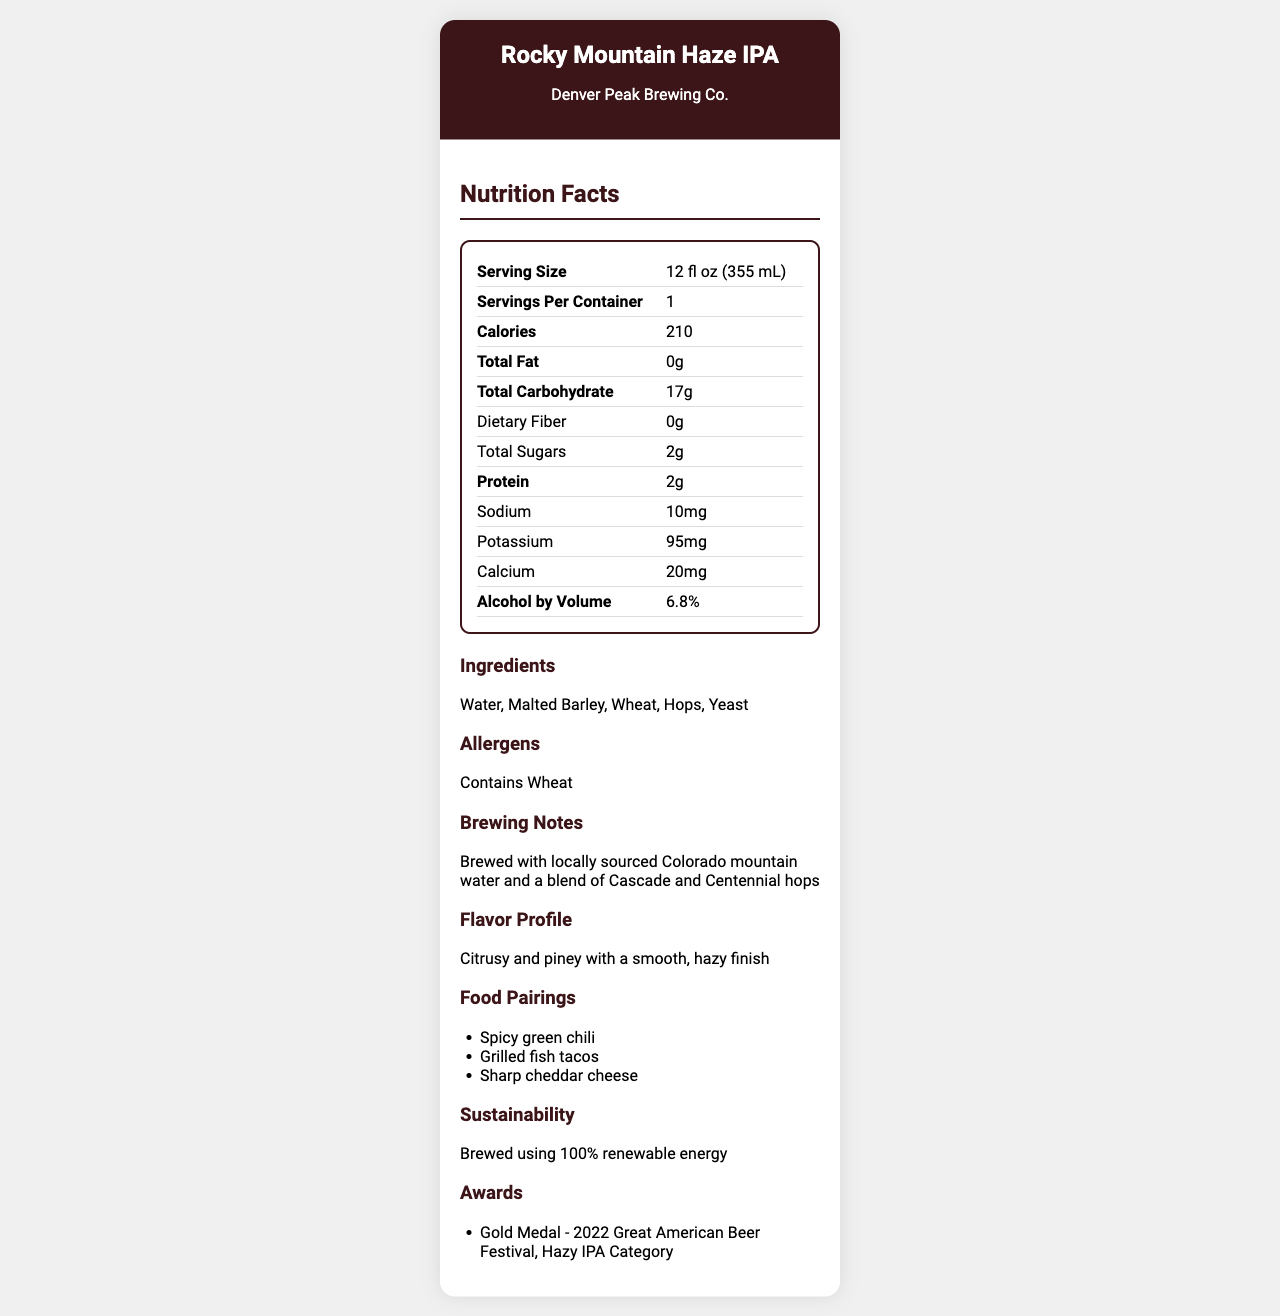what is the serving size of Rocky Mountain Haze IPA? The serving size is listed as "12 fl oz (355 mL)" in the Nutrition Facts table.
Answer: 12 fl oz (355 mL) how many carbohydrates are in a serving? The Nutrition Facts section indicates that the total carbohydrate content per serving is 17 grams.
Answer: 17 grams what is the alcohol content of Rocky Mountain Haze IPA? The Alcohol by Volume (ABV) is stated as 6.8% in the Nutrition Facts section.
Answer: 6.8% how many calories are in one serving of Rocky Mountain Haze IPA? The number of calories per serving is given as 210 in the Nutrition Facts section.
Answer: 210 calories what ingredients are used to brew Rocky Mountain Haze IPA? The Ingredients section lists Water, Malted Barley, Wheat, Hops, and Yeast.
Answer: Water, Malted Barley, Wheat, Hops, Yeast how much protein is in a serving? The Nutrition Facts table shows that there are 2 grams of protein per serving.
Answer: 2 grams how much potassium does one serving contain? The amount of potassium per serving is listed as 95 milligrams in the Nutrition Facts section.
Answer: 95 milligrams which allergen is mentioned for Rocky Mountain Haze IPA? The Allergens section specifies that the product contains Wheat.
Answer: Wheat What is the brewery that produces Rocky Mountain Haze IPA? The document mentions that the brewery is Denver Peak Brewing Co.
Answer: Denver Peak Brewing Co. what award did Rocky Mountain Haze IPA win? The Awards section states that the beer won the Gold Medal in the Hazy IPA Category at the 2022 Great American Beer Festival.
Answer: Gold Medal - 2022 Great American Beer Festival, Hazy IPA Category what is the flavor profile of Rocky Mountain Haze IPA? The Flavor Profile section describes it as "Citrusy and piney with a smooth, hazy finish."
Answer: Citrusy and piney with a smooth, hazy finish what food pairings are suggested for Rocky Mountain Haze IPA? A. Grilled chicken B. Spicy green chili C. Caesar salad D. Sushi The Food Pairings section suggests Spicy green chili, Grilled fish tacos, and Sharp cheddar cheese. Option B is correct.
Answer: B What is the sustainability feature of Rocky Mountain Haze IPA? I. Recycled packaging II. Brewed using 100% renewable energy III. Organic ingredients IV. Low water usage The Sustainability section mentions that the beer is brewed using 100% renewable energy, so option II is correct.
Answer: II is there any added sugar in Rocky Mountain Haze IPA? The Total Sugars section shows that the added sugars are 0 grams.
Answer: No describe the main idea of the document. The main idea encapsulates the nutritional information, brewing details, and additional insights about the Rocky Mountain Haze IPA from Denver Peak Brewing Co.
Answer: The document provides an overview of Rocky Mountain Haze IPA from Denver Peak Brewing Co. It includes nutrition facts, ingredients, allergens, brewing notes, flavor profile, food pairings, sustainability practices, and awards. how much sodium is in a serving of Rocky Mountain Haze IPA? The Nutrition Facts section specifies that there are 10 milligrams of sodium per serving.
Answer: 10 mg what are the brewing notes mentioned for Rocky Mountain Haze IPA? The Brewing Notes section describes that the beer is brewed with locally sourced Colorado mountain water and a blend of Cascade and Centennial hops.
Answer: Brewed with locally sourced Colorado mountain water and a blend of Cascade and Centennial hops how many servings per container are there? The Nutrition Facts table mentions that there is 1 serving per container.
Answer: 1 what is the calcium content in one serving? The Nutrition Facts section lists the calcium content as 20 milligrams per serving.
Answer: 20 milligrams what is the fat content in Rocky Mountain Haze IPA? The Nutrition Facts table indicates that the total fat content is 0 grams in one serving.
Answer: 0 grams are there any hops in Rocky Mountain Haze IPA? The ingredients list includes Hops, confirming their presence in the beer.
Answer: Yes Can you determine the brewing duration for Rocky Mountain Haze IPA from the document? The document does not provide any details about the brewing duration.
Answer: Not enough information 